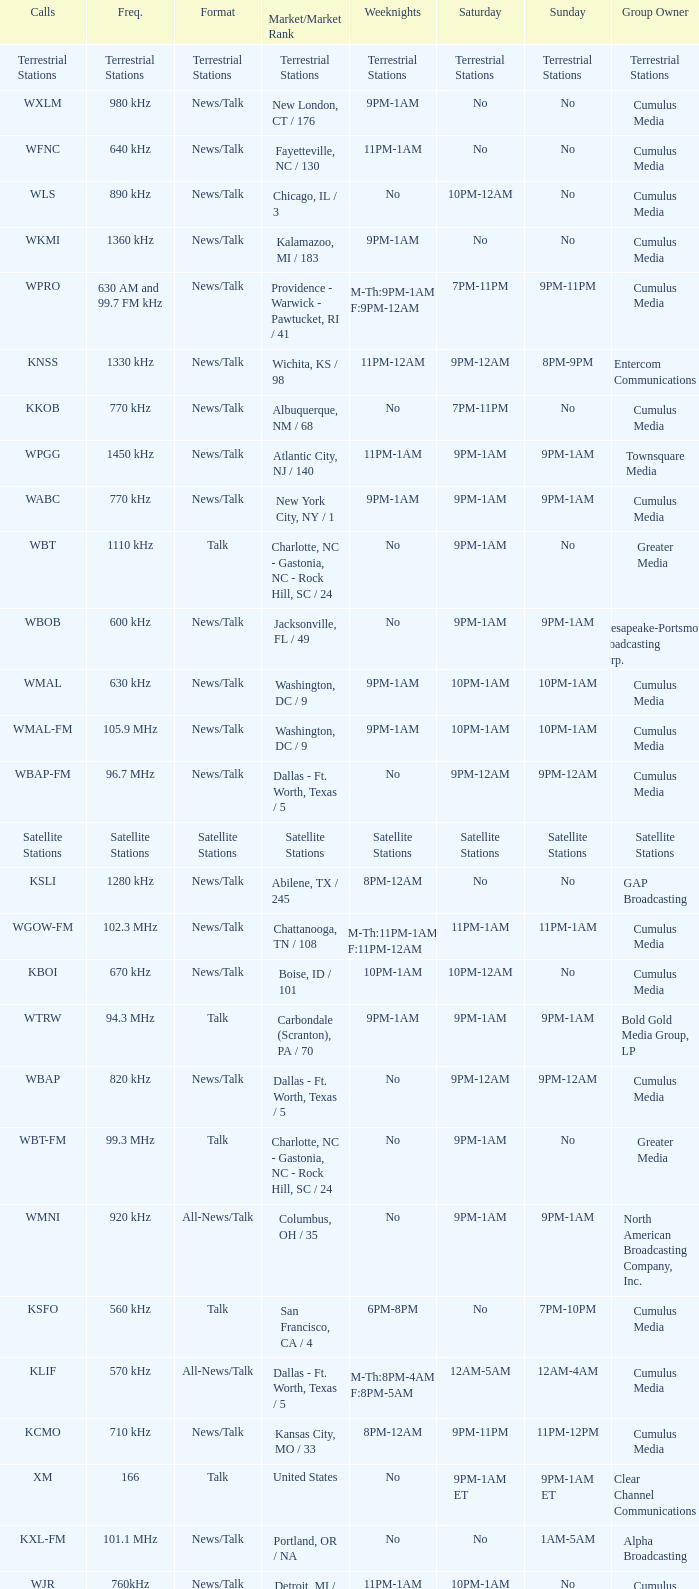Write the full table. {'header': ['Calls', 'Freq.', 'Format', 'Market/Market Rank', 'Weeknights', 'Saturday', 'Sunday', 'Group Owner'], 'rows': [['Terrestrial Stations', 'Terrestrial Stations', 'Terrestrial Stations', 'Terrestrial Stations', 'Terrestrial Stations', 'Terrestrial Stations', 'Terrestrial Stations', 'Terrestrial Stations'], ['WXLM', '980 kHz', 'News/Talk', 'New London, CT / 176', '9PM-1AM', 'No', 'No', 'Cumulus Media'], ['WFNC', '640 kHz', 'News/Talk', 'Fayetteville, NC / 130', '11PM-1AM', 'No', 'No', 'Cumulus Media'], ['WLS', '890 kHz', 'News/Talk', 'Chicago, IL / 3', 'No', '10PM-12AM', 'No', 'Cumulus Media'], ['WKMI', '1360 kHz', 'News/Talk', 'Kalamazoo, MI / 183', '9PM-1AM', 'No', 'No', 'Cumulus Media'], ['WPRO', '630 AM and 99.7 FM kHz', 'News/Talk', 'Providence - Warwick - Pawtucket, RI / 41', 'M-Th:9PM-1AM F:9PM-12AM', '7PM-11PM', '9PM-11PM', 'Cumulus Media'], ['KNSS', '1330 kHz', 'News/Talk', 'Wichita, KS / 98', '11PM-12AM', '9PM-12AM', '8PM-9PM', 'Entercom Communications'], ['KKOB', '770 kHz', 'News/Talk', 'Albuquerque, NM / 68', 'No', '7PM-11PM', 'No', 'Cumulus Media'], ['WPGG', '1450 kHz', 'News/Talk', 'Atlantic City, NJ / 140', '11PM-1AM', '9PM-1AM', '9PM-1AM', 'Townsquare Media'], ['WABC', '770 kHz', 'News/Talk', 'New York City, NY / 1', '9PM-1AM', '9PM-1AM', '9PM-1AM', 'Cumulus Media'], ['WBT', '1110 kHz', 'Talk', 'Charlotte, NC - Gastonia, NC - Rock Hill, SC / 24', 'No', '9PM-1AM', 'No', 'Greater Media'], ['WBOB', '600 kHz', 'News/Talk', 'Jacksonville, FL / 49', 'No', '9PM-1AM', '9PM-1AM', 'Chesapeake-Portsmouth Broadcasting Corp.'], ['WMAL', '630 kHz', 'News/Talk', 'Washington, DC / 9', '9PM-1AM', '10PM-1AM', '10PM-1AM', 'Cumulus Media'], ['WMAL-FM', '105.9 MHz', 'News/Talk', 'Washington, DC / 9', '9PM-1AM', '10PM-1AM', '10PM-1AM', 'Cumulus Media'], ['WBAP-FM', '96.7 MHz', 'News/Talk', 'Dallas - Ft. Worth, Texas / 5', 'No', '9PM-12AM', '9PM-12AM', 'Cumulus Media'], ['Satellite Stations', 'Satellite Stations', 'Satellite Stations', 'Satellite Stations', 'Satellite Stations', 'Satellite Stations', 'Satellite Stations', 'Satellite Stations'], ['KSLI', '1280 kHz', 'News/Talk', 'Abilene, TX / 245', '8PM-12AM', 'No', 'No', 'GAP Broadcasting'], ['WGOW-FM', '102.3 MHz', 'News/Talk', 'Chattanooga, TN / 108', 'M-Th:11PM-1AM F:11PM-12AM', '11PM-1AM', '11PM-1AM', 'Cumulus Media'], ['KBOI', '670 kHz', 'News/Talk', 'Boise, ID / 101', '10PM-1AM', '10PM-12AM', 'No', 'Cumulus Media'], ['WTRW', '94.3 MHz', 'Talk', 'Carbondale (Scranton), PA / 70', '9PM-1AM', '9PM-1AM', '9PM-1AM', 'Bold Gold Media Group, LP'], ['WBAP', '820 kHz', 'News/Talk', 'Dallas - Ft. Worth, Texas / 5', 'No', '9PM-12AM', '9PM-12AM', 'Cumulus Media'], ['WBT-FM', '99.3 MHz', 'Talk', 'Charlotte, NC - Gastonia, NC - Rock Hill, SC / 24', 'No', '9PM-1AM', 'No', 'Greater Media'], ['WMNI', '920 kHz', 'All-News/Talk', 'Columbus, OH / 35', 'No', '9PM-1AM', '9PM-1AM', 'North American Broadcasting Company, Inc.'], ['KSFO', '560 kHz', 'Talk', 'San Francisco, CA / 4', '6PM-8PM', 'No', '7PM-10PM', 'Cumulus Media'], ['KLIF', '570 kHz', 'All-News/Talk', 'Dallas - Ft. Worth, Texas / 5', 'M-Th:8PM-4AM F:8PM-5AM', '12AM-5AM', '12AM-4AM', 'Cumulus Media'], ['KCMO', '710 kHz', 'News/Talk', 'Kansas City, MO / 33', '8PM-12AM', '9PM-11PM', '11PM-12PM', 'Cumulus Media'], ['XM', '166', 'Talk', 'United States', 'No', '9PM-1AM ET', '9PM-1AM ET', 'Clear Channel Communications'], ['KXL-FM', '101.1 MHz', 'News/Talk', 'Portland, OR / NA', 'No', 'No', '1AM-5AM', 'Alpha Broadcasting'], ['WJR', '760kHz', 'News/Talk', 'Detroit, MI / 11', '11PM-1AM', '10PM-1AM', 'No', 'Cumulus Media'], ['KROI', '92.1 MHz', 'News', 'Houston / 6', 'No', '8PM-12AM', '8PM-12AM', 'Radio One'], ['WWXL', '1450 kHz', 'Talk', 'Manchester, Kentucky / NA', '9PM-1AM', 'No', 'No', 'Juanita Nolan'], ['WJKR', '103.9 MHz', 'All-News/Talk', 'Columbus, OH / 35', 'No', '9PM-1AM', '9PM-1AM', 'North American Broadcasting Company, Inc.']]} What is the market for the 11pm-1am Saturday game? Chattanooga, TN / 108. 